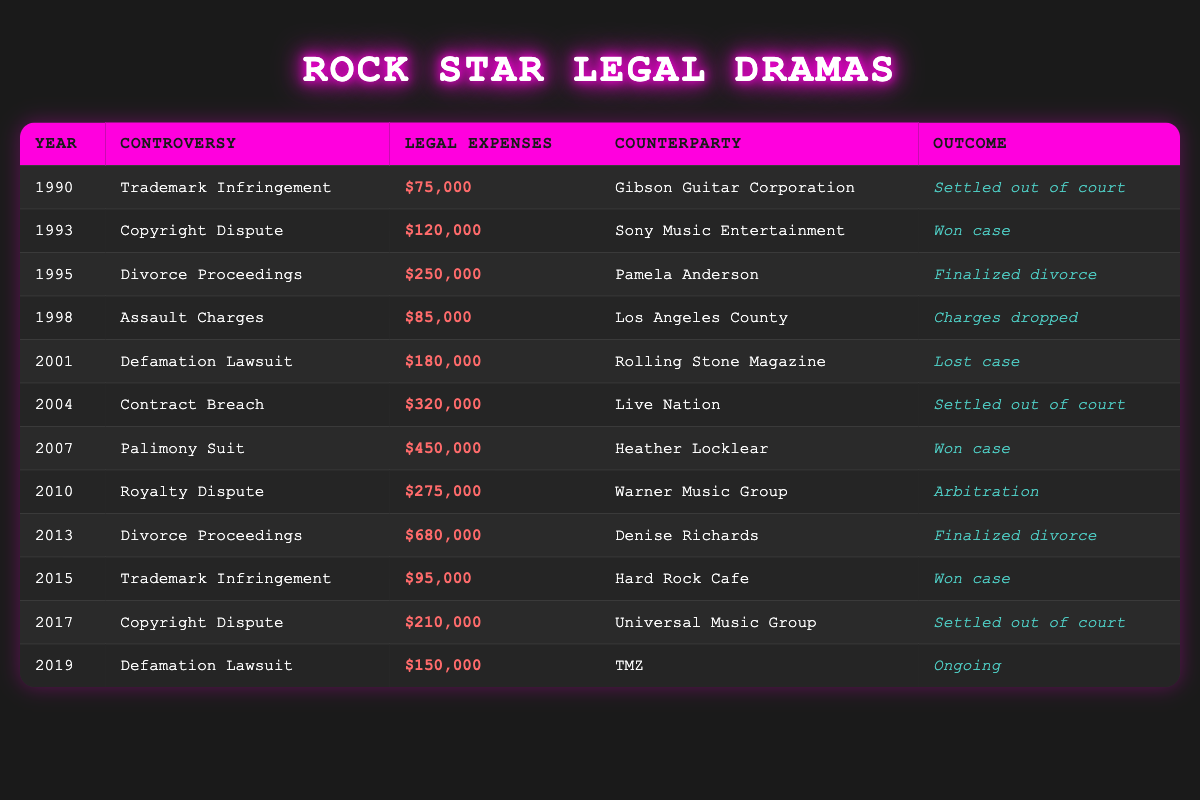What were the legal expenses in 1995? The table lists the legal expenses for each year. In 1995, the legal expenses were reported as $250,000.
Answer: $250,000 Which controversy had the highest legal expenses? By examining the legal expenses in the table, the highest amount is $680,000 for the "Divorce Proceedings" in 2013.
Answer: $680,000 How many controversies resulted in a favorable outcome (considering "Won case" and "Finalized divorce")? Looking at the table, the outcomes that are considered favorable include 1993 (Won case), 2007 (Won case), 2013 (Finalized divorce), and 1995 (Finalized divorce). Thus, there are 4 such outcomes.
Answer: 4 What is the total amount spent on legal expenses for "Divorce Proceedings"? The legal expenses for "Divorce Proceedings" can be found in two entries: $250,000 in 1995 and $680,000 in 2013. Adding these together gives $250,000 + $680,000 = $930,000.
Answer: $930,000 Did any controversies occur in the 2000s that resulted in an ongoing outcome? The only ongoing outcome listed in the table is for the year 2019 regarding the "Defamation Lawsuit" with TMZ. All other controversies in the 2000s do not show ongoing outcomes.
Answer: No Which counterparty had the lowest legal expenses in a controversy? The row with the lowest legal expenses can be identified in the table where the legal expenses amount is $75,000 with Gibson Guitar Corporation in 1990 for "Trademark Infringement."
Answer: $75,000 What is the average legal expense for controversies resulting in arbitration? The only arbitration listed is in 2010, where the legal expenses were $275,000. Since there is only one entry, the average is simply $275,000.
Answer: $275,000 Were there more controversies involving "Trademark Infringement" or "Copyright Dispute"? The table shows "Trademark Infringement" occurring in 1990 and 2015 (2 times) and "Copyright Dispute" occurring in 1993 and 2017 (also 2 times). Therefore, they are equal in terms of frequency.
Answer: Equal (2 each) 